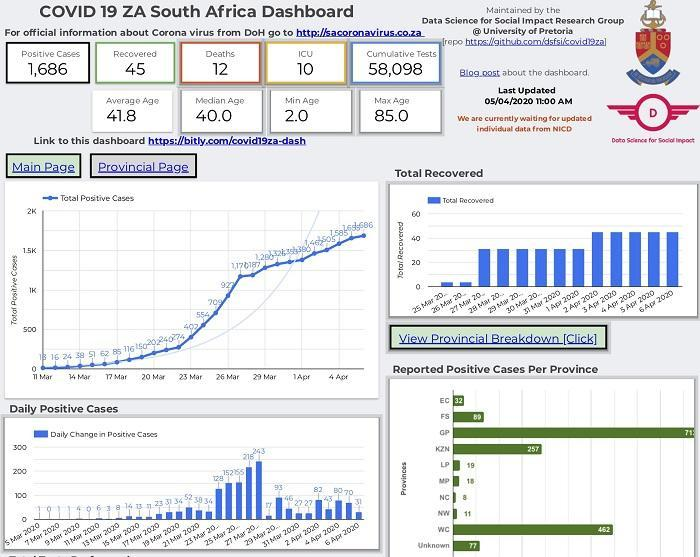What is the maximum age?
Answer the question with a short phrase. 85.0 What is the average age? 41.8 What is the total number of cases in EC and NC, taken together? 40 What is the total number of cases on the 12th and 13th of march, taken together? 40 What is the number of deaths? 12 What is the minimum age? 2.0 What is the total number of cases on the 20th and 17th of march, taken together? 287 